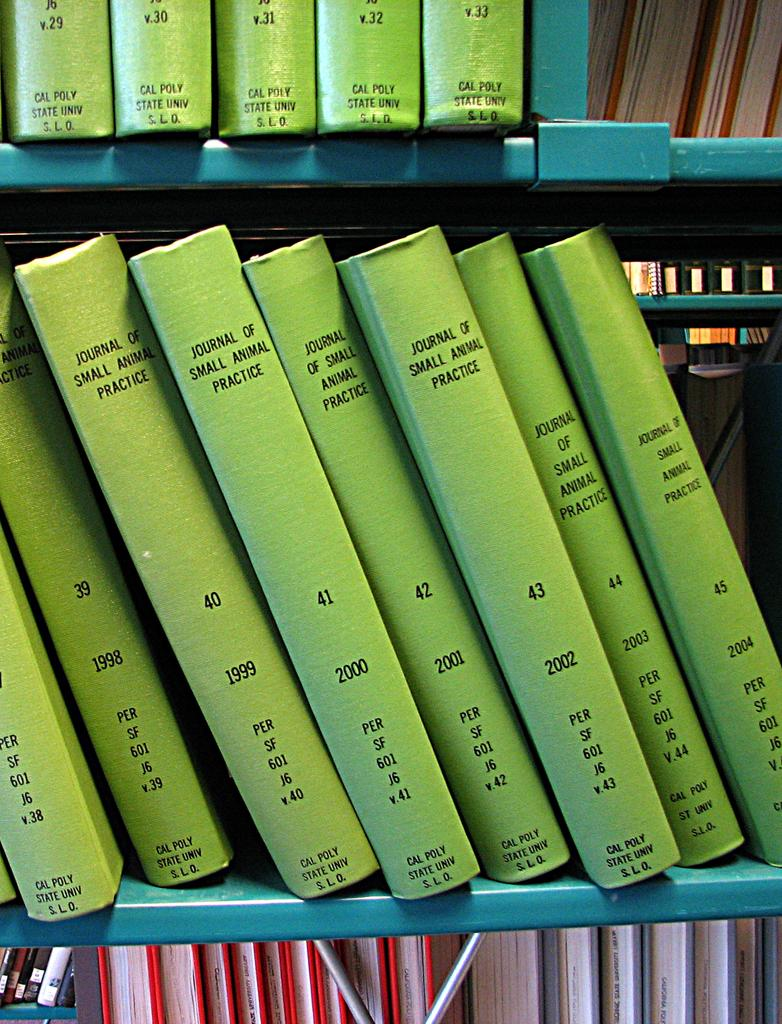<image>
Create a compact narrative representing the image presented. Many volumes of the Journal of Small Animal Practice are lined up on a library shelf. 